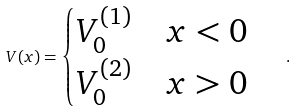<formula> <loc_0><loc_0><loc_500><loc_500>V ( x ) = \begin{cases} V _ { 0 } ^ { ( 1 ) } & \text {$x < 0$} \\ V _ { 0 } ^ { ( 2 ) } & \text {$x > 0$} \end{cases} \quad .</formula> 